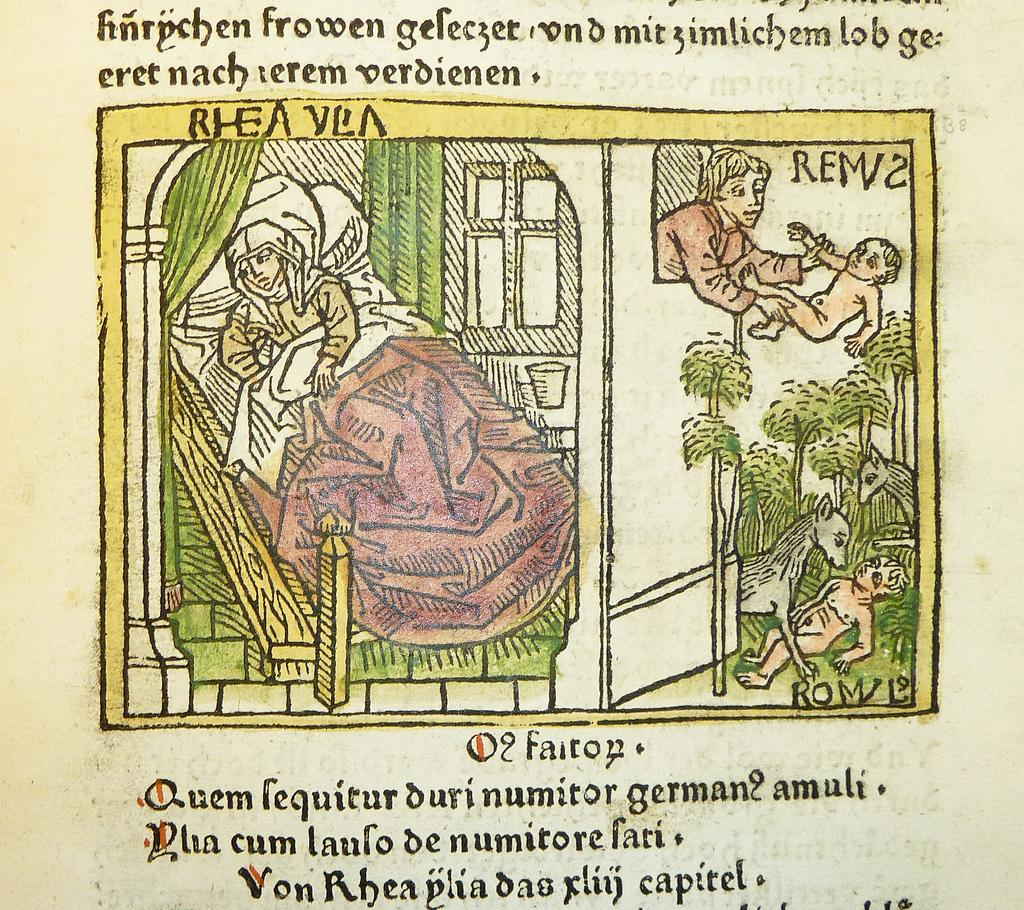What type of images are present in the picture? There are cartoon images of people, an animal, and trees in the picture. What else can be seen in the picture besides the cartoon images? There is text visible in the picture. How many brothers are depicted in the cartoon image of people in the picture? There is no information about brothers in the image, as it only contains cartoon images of people, an animal, trees, and text. 